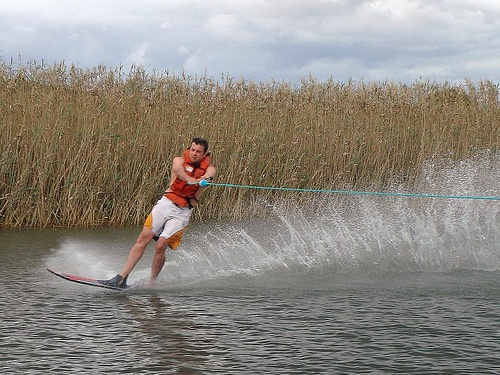Describe the objects in this image and their specific colors. I can see people in white, brown, darkgray, maroon, and lightgray tones and surfboard in white, darkgray, gray, black, and brown tones in this image. 